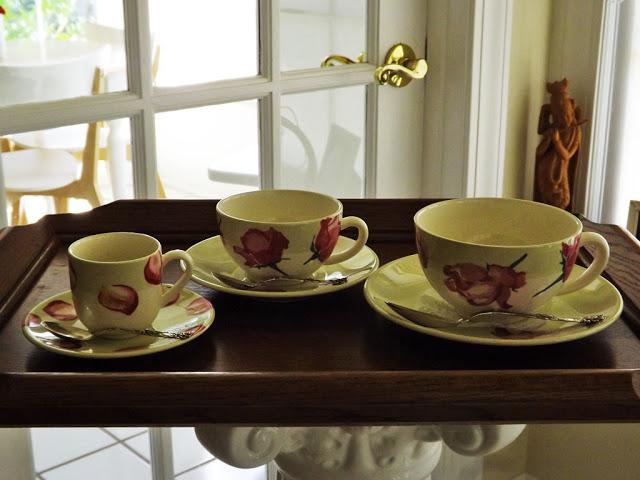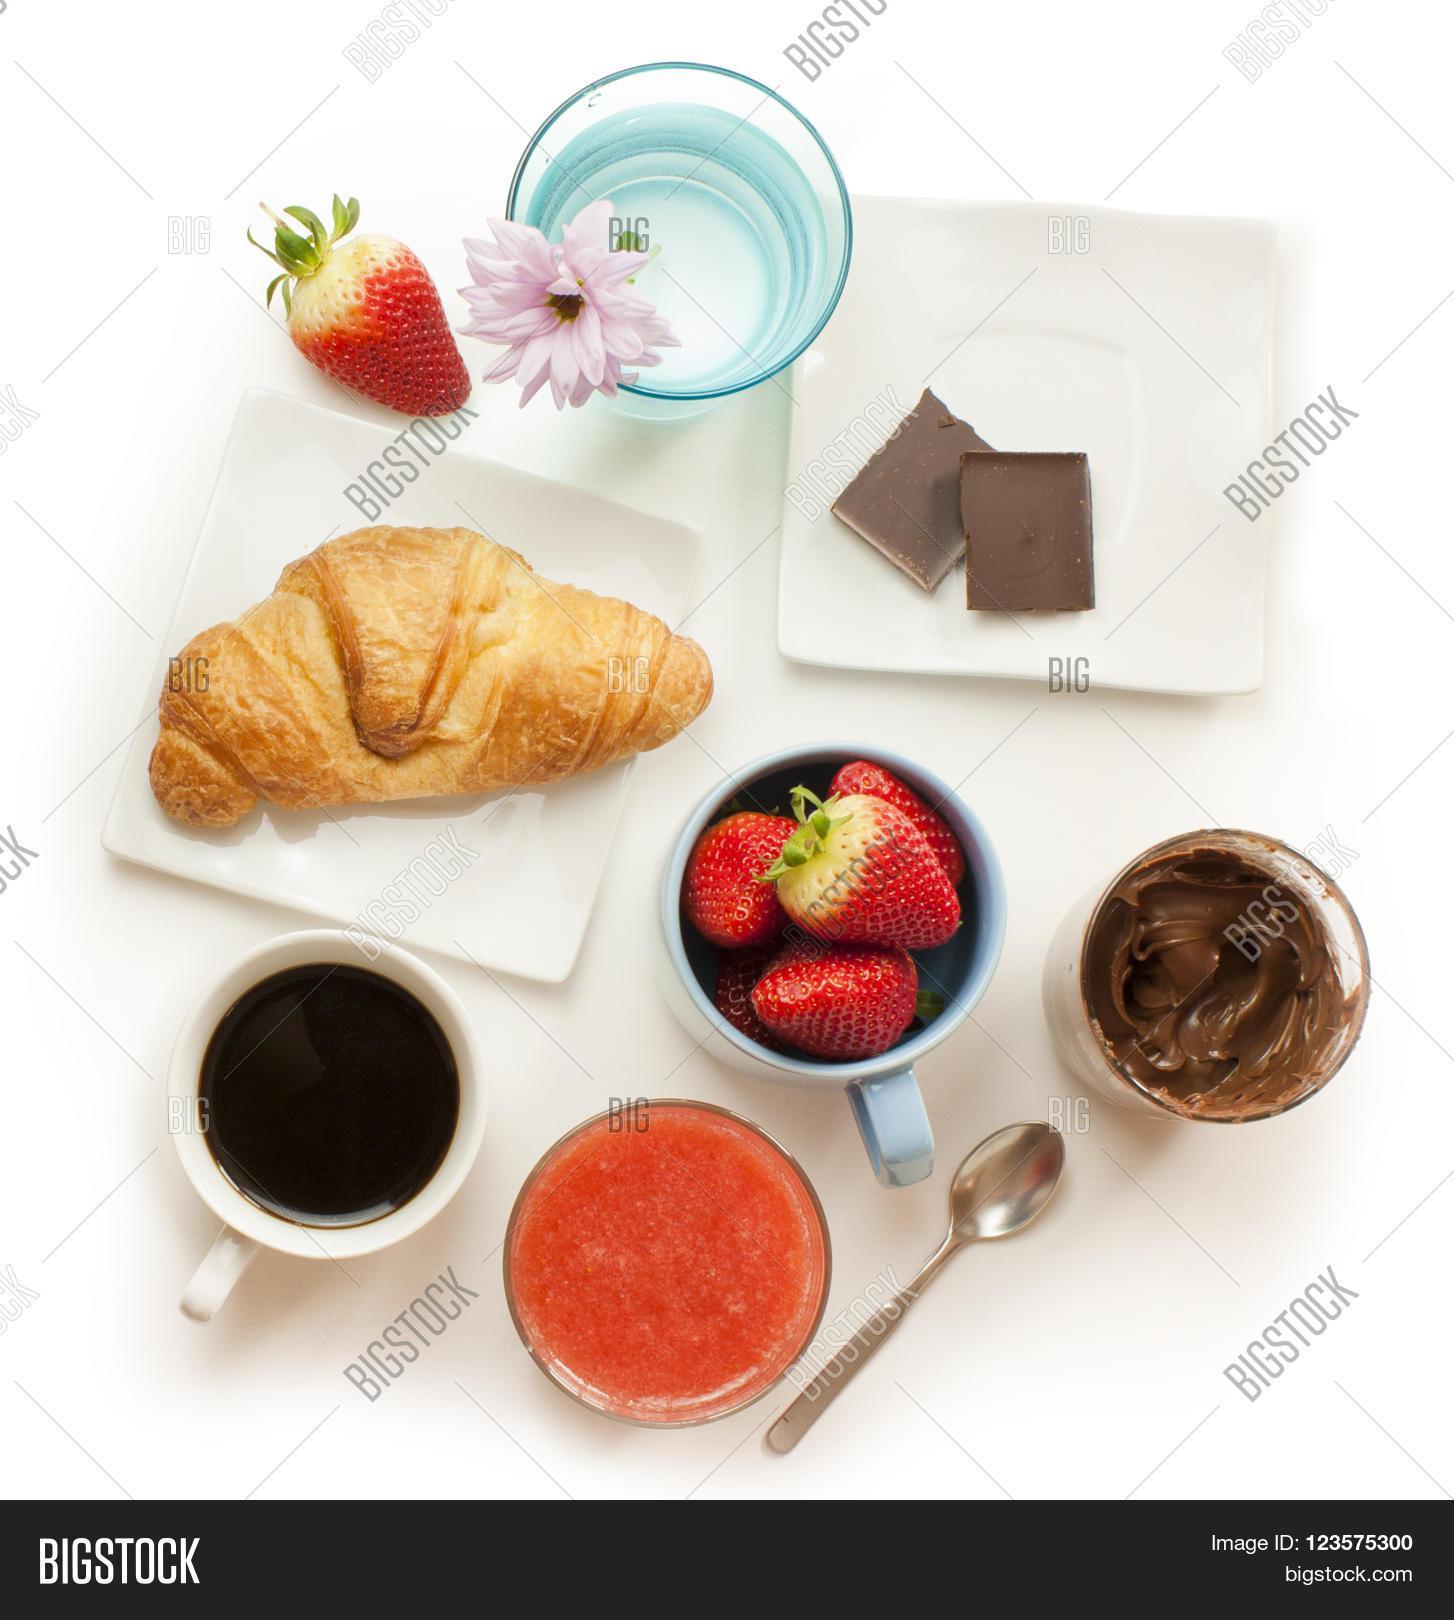The first image is the image on the left, the second image is the image on the right. Considering the images on both sides, is "In one image, a bouquet of flowers is near two cups of coffee, while the second image shows one or more cups of coffee with matching saucers." valid? Answer yes or no. No. The first image is the image on the left, the second image is the image on the right. Given the left and right images, does the statement "An image shows a container of fresh flowers and a tray containing two filled beverage cups." hold true? Answer yes or no. No. 